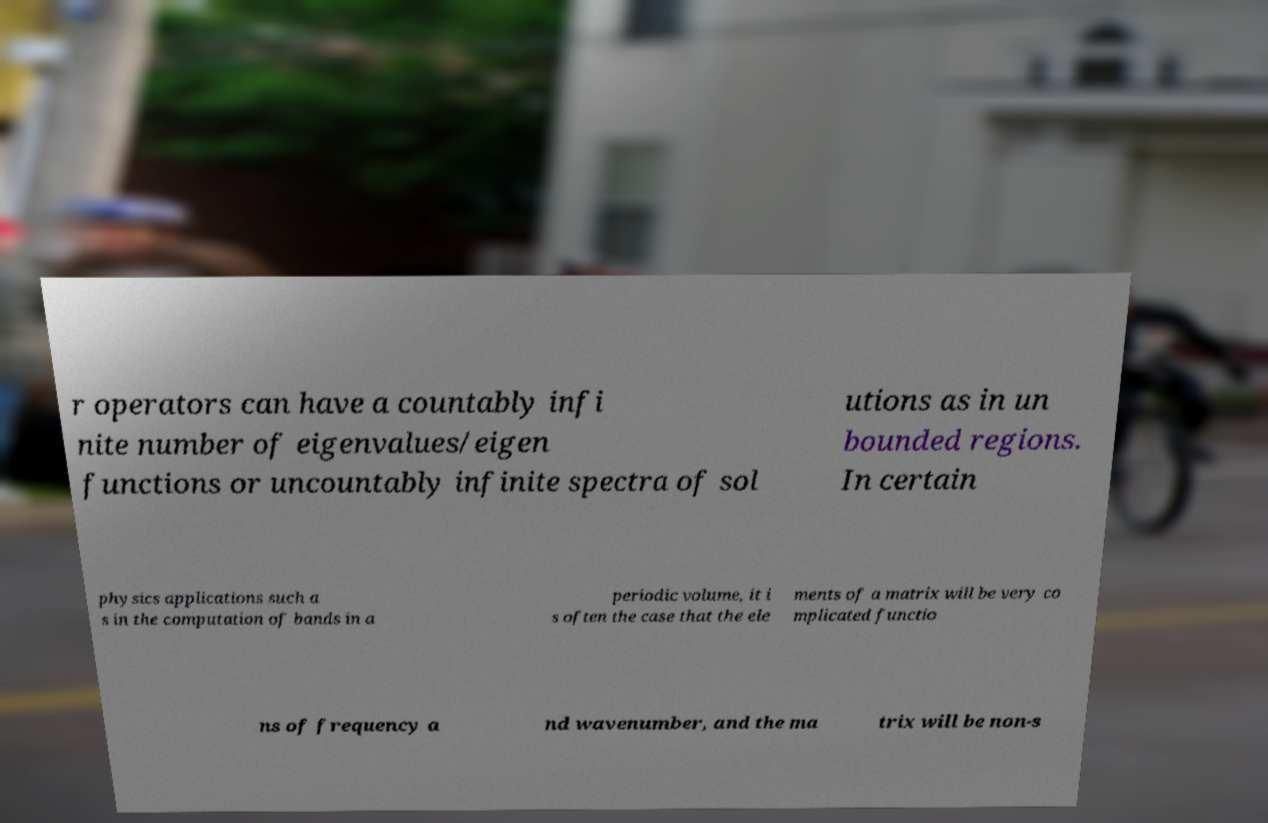Can you accurately transcribe the text from the provided image for me? r operators can have a countably infi nite number of eigenvalues/eigen functions or uncountably infinite spectra of sol utions as in un bounded regions. In certain physics applications such a s in the computation of bands in a periodic volume, it i s often the case that the ele ments of a matrix will be very co mplicated functio ns of frequency a nd wavenumber, and the ma trix will be non-s 